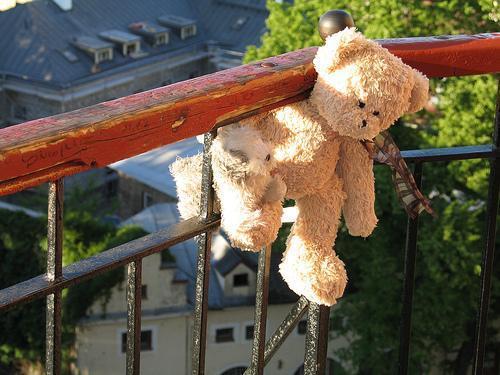How many teddy bears are there?
Give a very brief answer. 2. 